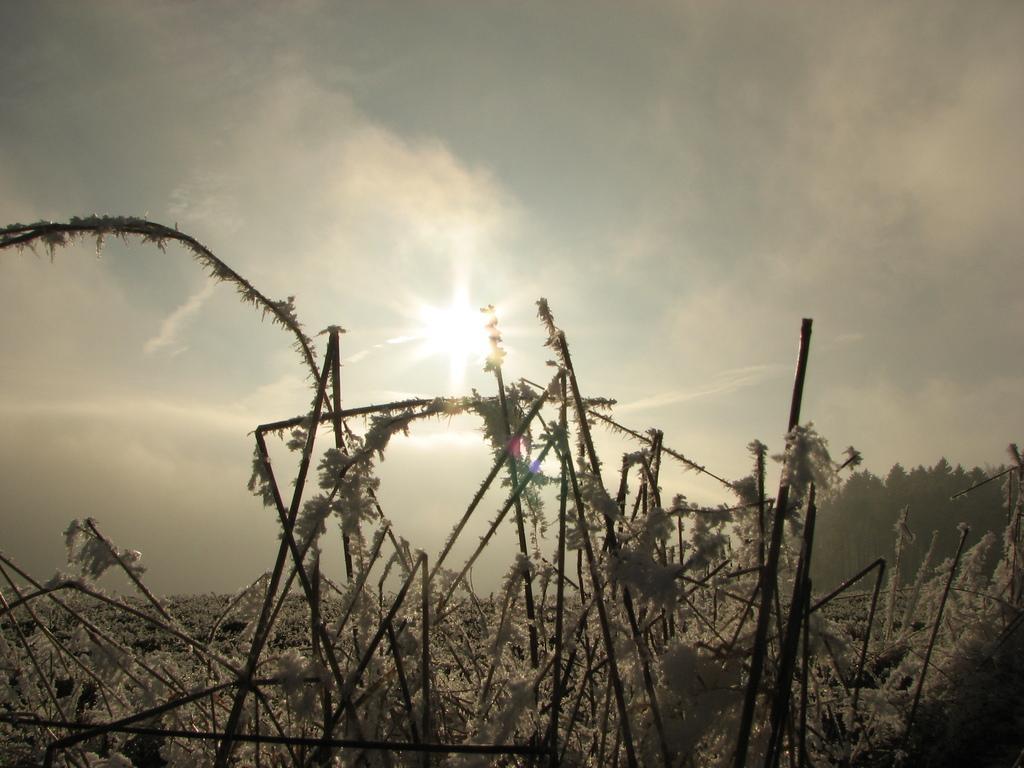Describe this image in one or two sentences. In this image, we can see twigs covered by ice and in the background, there are trees and we can see sunlight. 